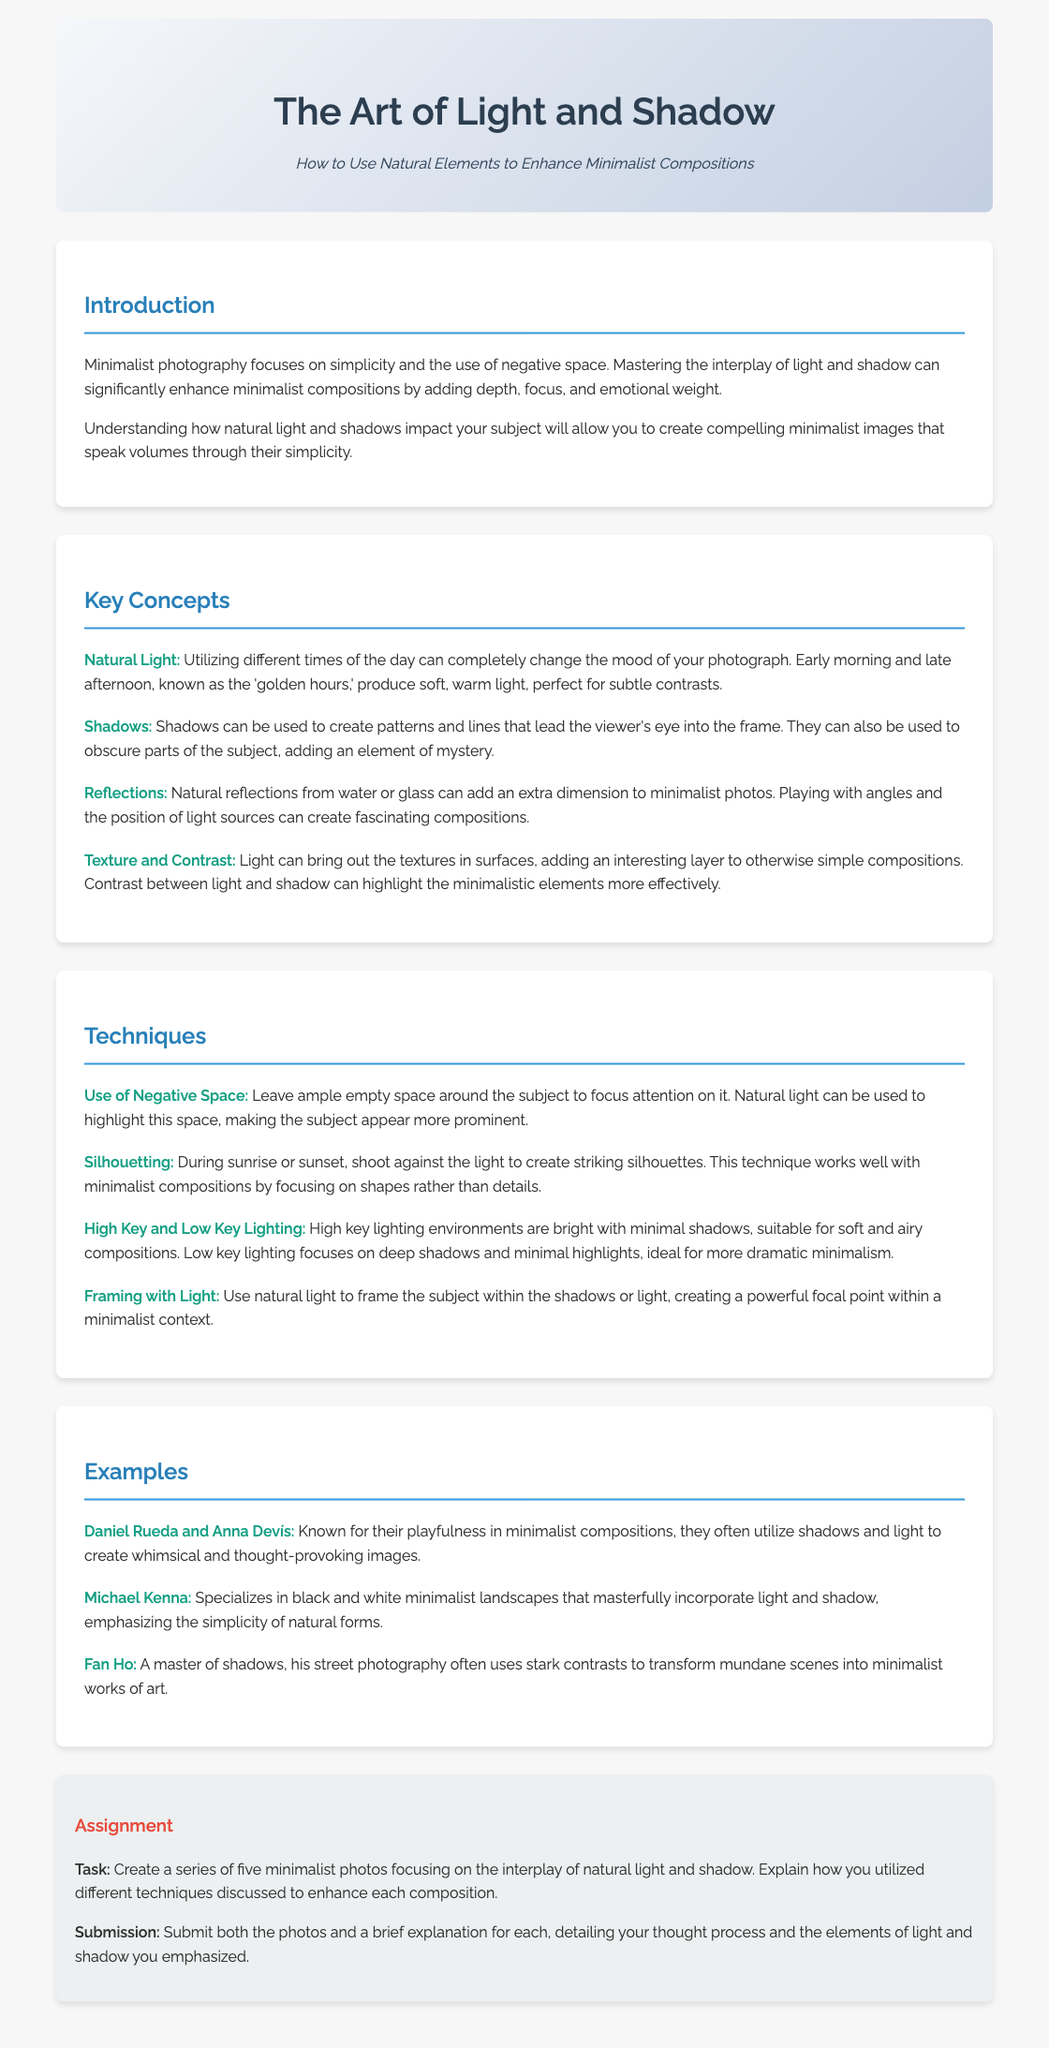What are the golden hours? The golden hours refer to early morning and late afternoon, known for producing soft, warm light ideal for photographs.
Answer: Early morning and late afternoon Which technique involves shooting against the light? Shooting against the light during sunrise or sunset creates striking silhouettes, a technique that works well in minimalist compositions.
Answer: Silhouetting Who is known for whimsical minimalist compositions? Daniel Rueda and Anna Devís are recognized for their playful minimalist images utilizing shadows and light.
Answer: Daniel Rueda and Anna Devís What does high key lighting focus on? High key lighting environments are characterized by being bright with minimal shadows, suitable for soft compositions.
Answer: Minimal shadows What is the assignment task? The task involves creating a series of five minimalist photos focusing on natural light and shadow interactions and explaining the techniques used.
Answer: Create a series of five minimalist photos 